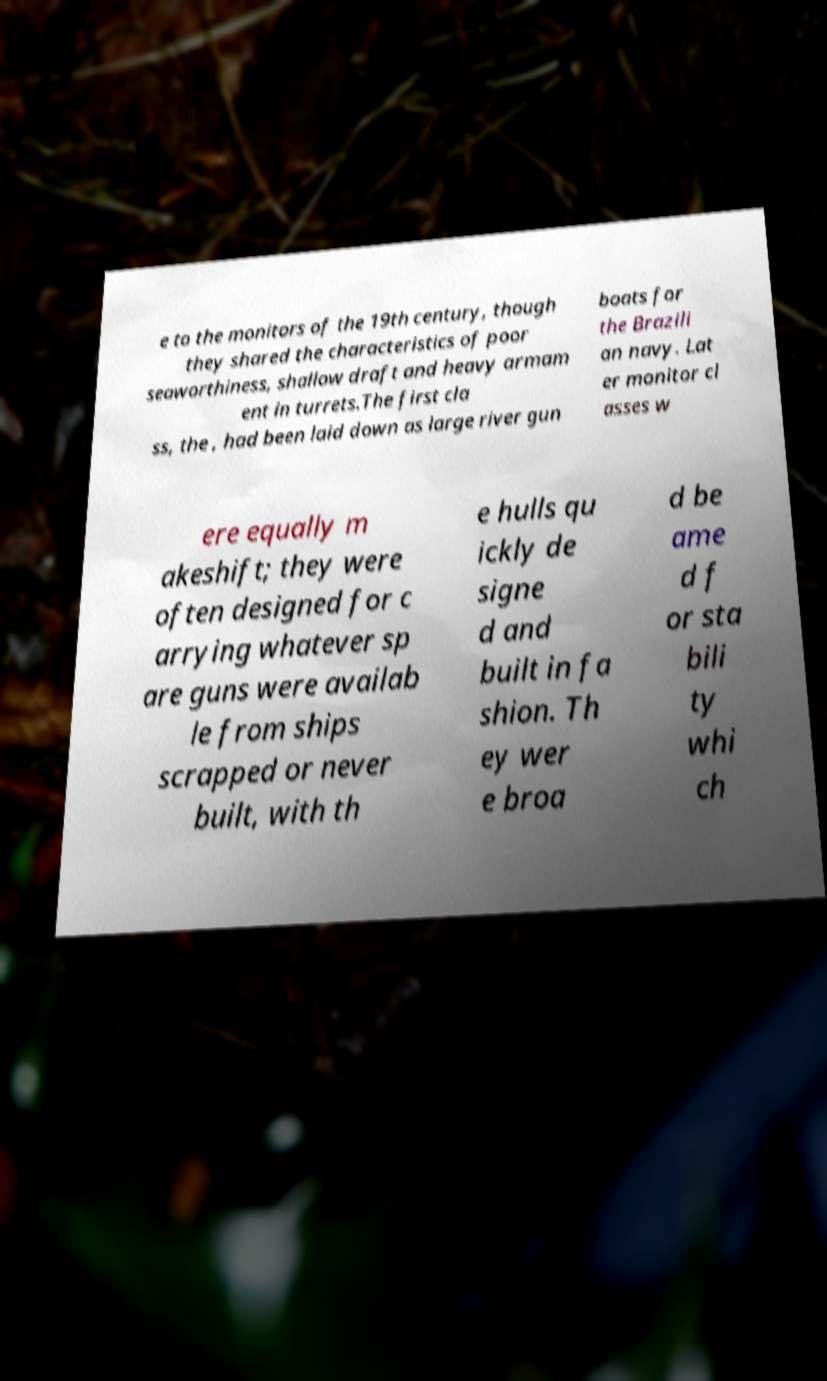For documentation purposes, I need the text within this image transcribed. Could you provide that? e to the monitors of the 19th century, though they shared the characteristics of poor seaworthiness, shallow draft and heavy armam ent in turrets.The first cla ss, the , had been laid down as large river gun boats for the Brazili an navy. Lat er monitor cl asses w ere equally m akeshift; they were often designed for c arrying whatever sp are guns were availab le from ships scrapped or never built, with th e hulls qu ickly de signe d and built in fa shion. Th ey wer e broa d be ame d f or sta bili ty whi ch 